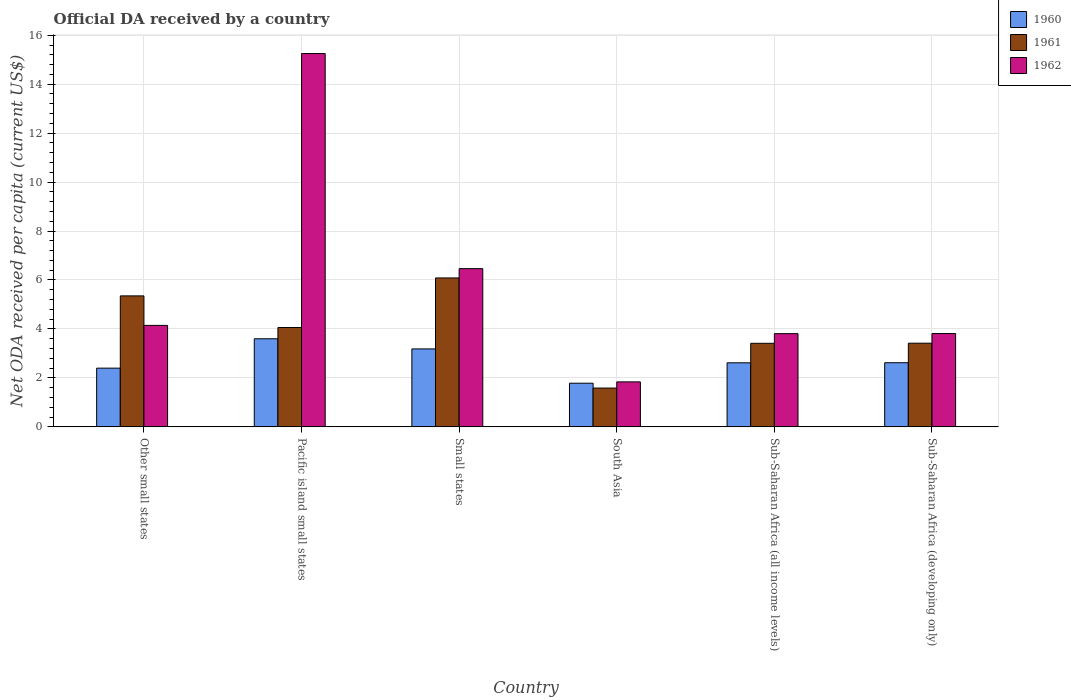How many different coloured bars are there?
Make the answer very short. 3. How many groups of bars are there?
Provide a short and direct response. 6. Are the number of bars on each tick of the X-axis equal?
Your response must be concise. Yes. How many bars are there on the 2nd tick from the left?
Your response must be concise. 3. How many bars are there on the 4th tick from the right?
Your answer should be compact. 3. What is the label of the 2nd group of bars from the left?
Offer a very short reply. Pacific island small states. In how many cases, is the number of bars for a given country not equal to the number of legend labels?
Offer a very short reply. 0. What is the ODA received in in 1961 in Other small states?
Provide a succinct answer. 5.35. Across all countries, what is the maximum ODA received in in 1961?
Make the answer very short. 6.08. Across all countries, what is the minimum ODA received in in 1960?
Your answer should be compact. 1.78. In which country was the ODA received in in 1960 maximum?
Your response must be concise. Pacific island small states. What is the total ODA received in in 1962 in the graph?
Provide a short and direct response. 35.32. What is the difference between the ODA received in in 1961 in Small states and that in Sub-Saharan Africa (developing only)?
Give a very brief answer. 2.67. What is the difference between the ODA received in in 1960 in South Asia and the ODA received in in 1961 in Other small states?
Your answer should be compact. -3.57. What is the average ODA received in in 1961 per country?
Ensure brevity in your answer.  3.99. What is the difference between the ODA received in of/in 1962 and ODA received in of/in 1961 in Small states?
Offer a very short reply. 0.38. In how many countries, is the ODA received in in 1962 greater than 2 US$?
Provide a succinct answer. 5. What is the ratio of the ODA received in in 1961 in Sub-Saharan Africa (all income levels) to that in Sub-Saharan Africa (developing only)?
Offer a terse response. 1. Is the ODA received in in 1961 in Sub-Saharan Africa (all income levels) less than that in Sub-Saharan Africa (developing only)?
Give a very brief answer. Yes. What is the difference between the highest and the second highest ODA received in in 1960?
Ensure brevity in your answer.  0.56. What is the difference between the highest and the lowest ODA received in in 1960?
Provide a short and direct response. 1.82. In how many countries, is the ODA received in in 1962 greater than the average ODA received in in 1962 taken over all countries?
Ensure brevity in your answer.  2. Is the sum of the ODA received in in 1960 in Small states and South Asia greater than the maximum ODA received in in 1962 across all countries?
Provide a succinct answer. No. Is it the case that in every country, the sum of the ODA received in in 1962 and ODA received in in 1961 is greater than the ODA received in in 1960?
Provide a short and direct response. Yes. How many countries are there in the graph?
Offer a very short reply. 6. What is the difference between two consecutive major ticks on the Y-axis?
Your response must be concise. 2. Are the values on the major ticks of Y-axis written in scientific E-notation?
Ensure brevity in your answer.  No. What is the title of the graph?
Give a very brief answer. Official DA received by a country. What is the label or title of the Y-axis?
Give a very brief answer. Net ODA received per capita (current US$). What is the Net ODA received per capita (current US$) of 1960 in Other small states?
Give a very brief answer. 2.4. What is the Net ODA received per capita (current US$) in 1961 in Other small states?
Your response must be concise. 5.35. What is the Net ODA received per capita (current US$) in 1962 in Other small states?
Provide a succinct answer. 4.15. What is the Net ODA received per capita (current US$) of 1960 in Pacific island small states?
Make the answer very short. 3.6. What is the Net ODA received per capita (current US$) of 1961 in Pacific island small states?
Your answer should be very brief. 4.06. What is the Net ODA received per capita (current US$) in 1962 in Pacific island small states?
Give a very brief answer. 15.25. What is the Net ODA received per capita (current US$) in 1960 in Small states?
Your answer should be very brief. 3.18. What is the Net ODA received per capita (current US$) of 1961 in Small states?
Your answer should be very brief. 6.08. What is the Net ODA received per capita (current US$) in 1962 in Small states?
Provide a succinct answer. 6.46. What is the Net ODA received per capita (current US$) of 1960 in South Asia?
Provide a short and direct response. 1.78. What is the Net ODA received per capita (current US$) of 1961 in South Asia?
Offer a terse response. 1.59. What is the Net ODA received per capita (current US$) of 1962 in South Asia?
Provide a short and direct response. 1.84. What is the Net ODA received per capita (current US$) of 1960 in Sub-Saharan Africa (all income levels)?
Offer a very short reply. 2.62. What is the Net ODA received per capita (current US$) of 1961 in Sub-Saharan Africa (all income levels)?
Ensure brevity in your answer.  3.41. What is the Net ODA received per capita (current US$) of 1962 in Sub-Saharan Africa (all income levels)?
Your answer should be compact. 3.81. What is the Net ODA received per capita (current US$) of 1960 in Sub-Saharan Africa (developing only)?
Your answer should be compact. 2.62. What is the Net ODA received per capita (current US$) of 1961 in Sub-Saharan Africa (developing only)?
Give a very brief answer. 3.42. What is the Net ODA received per capita (current US$) in 1962 in Sub-Saharan Africa (developing only)?
Offer a terse response. 3.81. Across all countries, what is the maximum Net ODA received per capita (current US$) in 1960?
Ensure brevity in your answer.  3.6. Across all countries, what is the maximum Net ODA received per capita (current US$) in 1961?
Ensure brevity in your answer.  6.08. Across all countries, what is the maximum Net ODA received per capita (current US$) of 1962?
Your answer should be very brief. 15.25. Across all countries, what is the minimum Net ODA received per capita (current US$) in 1960?
Offer a terse response. 1.78. Across all countries, what is the minimum Net ODA received per capita (current US$) in 1961?
Your answer should be very brief. 1.59. Across all countries, what is the minimum Net ODA received per capita (current US$) of 1962?
Your answer should be very brief. 1.84. What is the total Net ODA received per capita (current US$) of 1960 in the graph?
Provide a succinct answer. 16.2. What is the total Net ODA received per capita (current US$) of 1961 in the graph?
Your answer should be compact. 23.91. What is the total Net ODA received per capita (current US$) of 1962 in the graph?
Provide a short and direct response. 35.32. What is the difference between the Net ODA received per capita (current US$) of 1960 in Other small states and that in Pacific island small states?
Offer a very short reply. -1.2. What is the difference between the Net ODA received per capita (current US$) in 1961 in Other small states and that in Pacific island small states?
Your answer should be very brief. 1.29. What is the difference between the Net ODA received per capita (current US$) in 1962 in Other small states and that in Pacific island small states?
Make the answer very short. -11.11. What is the difference between the Net ODA received per capita (current US$) of 1960 in Other small states and that in Small states?
Keep it short and to the point. -0.79. What is the difference between the Net ODA received per capita (current US$) of 1961 in Other small states and that in Small states?
Offer a terse response. -0.73. What is the difference between the Net ODA received per capita (current US$) of 1962 in Other small states and that in Small states?
Provide a succinct answer. -2.32. What is the difference between the Net ODA received per capita (current US$) of 1960 in Other small states and that in South Asia?
Give a very brief answer. 0.62. What is the difference between the Net ODA received per capita (current US$) of 1961 in Other small states and that in South Asia?
Give a very brief answer. 3.77. What is the difference between the Net ODA received per capita (current US$) in 1962 in Other small states and that in South Asia?
Ensure brevity in your answer.  2.31. What is the difference between the Net ODA received per capita (current US$) of 1960 in Other small states and that in Sub-Saharan Africa (all income levels)?
Give a very brief answer. -0.22. What is the difference between the Net ODA received per capita (current US$) of 1961 in Other small states and that in Sub-Saharan Africa (all income levels)?
Provide a succinct answer. 1.94. What is the difference between the Net ODA received per capita (current US$) in 1962 in Other small states and that in Sub-Saharan Africa (all income levels)?
Your response must be concise. 0.34. What is the difference between the Net ODA received per capita (current US$) of 1960 in Other small states and that in Sub-Saharan Africa (developing only)?
Provide a succinct answer. -0.22. What is the difference between the Net ODA received per capita (current US$) in 1961 in Other small states and that in Sub-Saharan Africa (developing only)?
Offer a terse response. 1.93. What is the difference between the Net ODA received per capita (current US$) in 1962 in Other small states and that in Sub-Saharan Africa (developing only)?
Provide a succinct answer. 0.33. What is the difference between the Net ODA received per capita (current US$) of 1960 in Pacific island small states and that in Small states?
Your answer should be very brief. 0.41. What is the difference between the Net ODA received per capita (current US$) of 1961 in Pacific island small states and that in Small states?
Provide a succinct answer. -2.03. What is the difference between the Net ODA received per capita (current US$) of 1962 in Pacific island small states and that in Small states?
Keep it short and to the point. 8.79. What is the difference between the Net ODA received per capita (current US$) of 1960 in Pacific island small states and that in South Asia?
Keep it short and to the point. 1.82. What is the difference between the Net ODA received per capita (current US$) in 1961 in Pacific island small states and that in South Asia?
Give a very brief answer. 2.47. What is the difference between the Net ODA received per capita (current US$) of 1962 in Pacific island small states and that in South Asia?
Offer a very short reply. 13.41. What is the difference between the Net ODA received per capita (current US$) of 1960 in Pacific island small states and that in Sub-Saharan Africa (all income levels)?
Provide a succinct answer. 0.98. What is the difference between the Net ODA received per capita (current US$) in 1961 in Pacific island small states and that in Sub-Saharan Africa (all income levels)?
Your answer should be compact. 0.64. What is the difference between the Net ODA received per capita (current US$) in 1962 in Pacific island small states and that in Sub-Saharan Africa (all income levels)?
Make the answer very short. 11.44. What is the difference between the Net ODA received per capita (current US$) of 1960 in Pacific island small states and that in Sub-Saharan Africa (developing only)?
Keep it short and to the point. 0.98. What is the difference between the Net ODA received per capita (current US$) of 1961 in Pacific island small states and that in Sub-Saharan Africa (developing only)?
Your response must be concise. 0.64. What is the difference between the Net ODA received per capita (current US$) in 1962 in Pacific island small states and that in Sub-Saharan Africa (developing only)?
Your answer should be very brief. 11.44. What is the difference between the Net ODA received per capita (current US$) of 1960 in Small states and that in South Asia?
Your response must be concise. 1.4. What is the difference between the Net ODA received per capita (current US$) in 1961 in Small states and that in South Asia?
Provide a succinct answer. 4.5. What is the difference between the Net ODA received per capita (current US$) in 1962 in Small states and that in South Asia?
Your answer should be very brief. 4.63. What is the difference between the Net ODA received per capita (current US$) in 1960 in Small states and that in Sub-Saharan Africa (all income levels)?
Give a very brief answer. 0.57. What is the difference between the Net ODA received per capita (current US$) of 1961 in Small states and that in Sub-Saharan Africa (all income levels)?
Your answer should be very brief. 2.67. What is the difference between the Net ODA received per capita (current US$) in 1962 in Small states and that in Sub-Saharan Africa (all income levels)?
Keep it short and to the point. 2.66. What is the difference between the Net ODA received per capita (current US$) in 1960 in Small states and that in Sub-Saharan Africa (developing only)?
Provide a short and direct response. 0.56. What is the difference between the Net ODA received per capita (current US$) in 1961 in Small states and that in Sub-Saharan Africa (developing only)?
Make the answer very short. 2.67. What is the difference between the Net ODA received per capita (current US$) in 1962 in Small states and that in Sub-Saharan Africa (developing only)?
Provide a short and direct response. 2.65. What is the difference between the Net ODA received per capita (current US$) in 1960 in South Asia and that in Sub-Saharan Africa (all income levels)?
Give a very brief answer. -0.83. What is the difference between the Net ODA received per capita (current US$) of 1961 in South Asia and that in Sub-Saharan Africa (all income levels)?
Make the answer very short. -1.83. What is the difference between the Net ODA received per capita (current US$) of 1962 in South Asia and that in Sub-Saharan Africa (all income levels)?
Ensure brevity in your answer.  -1.97. What is the difference between the Net ODA received per capita (current US$) of 1960 in South Asia and that in Sub-Saharan Africa (developing only)?
Provide a short and direct response. -0.84. What is the difference between the Net ODA received per capita (current US$) in 1961 in South Asia and that in Sub-Saharan Africa (developing only)?
Offer a terse response. -1.83. What is the difference between the Net ODA received per capita (current US$) in 1962 in South Asia and that in Sub-Saharan Africa (developing only)?
Offer a terse response. -1.98. What is the difference between the Net ODA received per capita (current US$) of 1960 in Sub-Saharan Africa (all income levels) and that in Sub-Saharan Africa (developing only)?
Provide a succinct answer. -0. What is the difference between the Net ODA received per capita (current US$) in 1961 in Sub-Saharan Africa (all income levels) and that in Sub-Saharan Africa (developing only)?
Provide a succinct answer. -0. What is the difference between the Net ODA received per capita (current US$) in 1962 in Sub-Saharan Africa (all income levels) and that in Sub-Saharan Africa (developing only)?
Offer a very short reply. -0. What is the difference between the Net ODA received per capita (current US$) of 1960 in Other small states and the Net ODA received per capita (current US$) of 1961 in Pacific island small states?
Offer a very short reply. -1.66. What is the difference between the Net ODA received per capita (current US$) of 1960 in Other small states and the Net ODA received per capita (current US$) of 1962 in Pacific island small states?
Your answer should be very brief. -12.85. What is the difference between the Net ODA received per capita (current US$) in 1961 in Other small states and the Net ODA received per capita (current US$) in 1962 in Pacific island small states?
Ensure brevity in your answer.  -9.9. What is the difference between the Net ODA received per capita (current US$) of 1960 in Other small states and the Net ODA received per capita (current US$) of 1961 in Small states?
Offer a terse response. -3.69. What is the difference between the Net ODA received per capita (current US$) in 1960 in Other small states and the Net ODA received per capita (current US$) in 1962 in Small states?
Keep it short and to the point. -4.06. What is the difference between the Net ODA received per capita (current US$) of 1961 in Other small states and the Net ODA received per capita (current US$) of 1962 in Small states?
Offer a very short reply. -1.11. What is the difference between the Net ODA received per capita (current US$) in 1960 in Other small states and the Net ODA received per capita (current US$) in 1961 in South Asia?
Your answer should be very brief. 0.81. What is the difference between the Net ODA received per capita (current US$) of 1960 in Other small states and the Net ODA received per capita (current US$) of 1962 in South Asia?
Ensure brevity in your answer.  0.56. What is the difference between the Net ODA received per capita (current US$) in 1961 in Other small states and the Net ODA received per capita (current US$) in 1962 in South Asia?
Your response must be concise. 3.51. What is the difference between the Net ODA received per capita (current US$) in 1960 in Other small states and the Net ODA received per capita (current US$) in 1961 in Sub-Saharan Africa (all income levels)?
Your answer should be compact. -1.02. What is the difference between the Net ODA received per capita (current US$) of 1960 in Other small states and the Net ODA received per capita (current US$) of 1962 in Sub-Saharan Africa (all income levels)?
Ensure brevity in your answer.  -1.41. What is the difference between the Net ODA received per capita (current US$) of 1961 in Other small states and the Net ODA received per capita (current US$) of 1962 in Sub-Saharan Africa (all income levels)?
Offer a very short reply. 1.54. What is the difference between the Net ODA received per capita (current US$) in 1960 in Other small states and the Net ODA received per capita (current US$) in 1961 in Sub-Saharan Africa (developing only)?
Give a very brief answer. -1.02. What is the difference between the Net ODA received per capita (current US$) of 1960 in Other small states and the Net ODA received per capita (current US$) of 1962 in Sub-Saharan Africa (developing only)?
Your answer should be very brief. -1.41. What is the difference between the Net ODA received per capita (current US$) in 1961 in Other small states and the Net ODA received per capita (current US$) in 1962 in Sub-Saharan Africa (developing only)?
Offer a very short reply. 1.54. What is the difference between the Net ODA received per capita (current US$) in 1960 in Pacific island small states and the Net ODA received per capita (current US$) in 1961 in Small states?
Provide a succinct answer. -2.48. What is the difference between the Net ODA received per capita (current US$) in 1960 in Pacific island small states and the Net ODA received per capita (current US$) in 1962 in Small states?
Keep it short and to the point. -2.86. What is the difference between the Net ODA received per capita (current US$) in 1961 in Pacific island small states and the Net ODA received per capita (current US$) in 1962 in Small states?
Keep it short and to the point. -2.41. What is the difference between the Net ODA received per capita (current US$) of 1960 in Pacific island small states and the Net ODA received per capita (current US$) of 1961 in South Asia?
Ensure brevity in your answer.  2.01. What is the difference between the Net ODA received per capita (current US$) of 1960 in Pacific island small states and the Net ODA received per capita (current US$) of 1962 in South Asia?
Your answer should be very brief. 1.76. What is the difference between the Net ODA received per capita (current US$) in 1961 in Pacific island small states and the Net ODA received per capita (current US$) in 1962 in South Asia?
Offer a terse response. 2.22. What is the difference between the Net ODA received per capita (current US$) in 1960 in Pacific island small states and the Net ODA received per capita (current US$) in 1961 in Sub-Saharan Africa (all income levels)?
Your answer should be compact. 0.18. What is the difference between the Net ODA received per capita (current US$) in 1960 in Pacific island small states and the Net ODA received per capita (current US$) in 1962 in Sub-Saharan Africa (all income levels)?
Give a very brief answer. -0.21. What is the difference between the Net ODA received per capita (current US$) of 1961 in Pacific island small states and the Net ODA received per capita (current US$) of 1962 in Sub-Saharan Africa (all income levels)?
Provide a short and direct response. 0.25. What is the difference between the Net ODA received per capita (current US$) in 1960 in Pacific island small states and the Net ODA received per capita (current US$) in 1961 in Sub-Saharan Africa (developing only)?
Your answer should be very brief. 0.18. What is the difference between the Net ODA received per capita (current US$) in 1960 in Pacific island small states and the Net ODA received per capita (current US$) in 1962 in Sub-Saharan Africa (developing only)?
Your response must be concise. -0.21. What is the difference between the Net ODA received per capita (current US$) in 1961 in Pacific island small states and the Net ODA received per capita (current US$) in 1962 in Sub-Saharan Africa (developing only)?
Keep it short and to the point. 0.25. What is the difference between the Net ODA received per capita (current US$) of 1960 in Small states and the Net ODA received per capita (current US$) of 1961 in South Asia?
Provide a succinct answer. 1.6. What is the difference between the Net ODA received per capita (current US$) of 1960 in Small states and the Net ODA received per capita (current US$) of 1962 in South Asia?
Your answer should be very brief. 1.35. What is the difference between the Net ODA received per capita (current US$) in 1961 in Small states and the Net ODA received per capita (current US$) in 1962 in South Asia?
Provide a short and direct response. 4.25. What is the difference between the Net ODA received per capita (current US$) in 1960 in Small states and the Net ODA received per capita (current US$) in 1961 in Sub-Saharan Africa (all income levels)?
Offer a terse response. -0.23. What is the difference between the Net ODA received per capita (current US$) of 1960 in Small states and the Net ODA received per capita (current US$) of 1962 in Sub-Saharan Africa (all income levels)?
Provide a succinct answer. -0.62. What is the difference between the Net ODA received per capita (current US$) of 1961 in Small states and the Net ODA received per capita (current US$) of 1962 in Sub-Saharan Africa (all income levels)?
Your response must be concise. 2.28. What is the difference between the Net ODA received per capita (current US$) in 1960 in Small states and the Net ODA received per capita (current US$) in 1961 in Sub-Saharan Africa (developing only)?
Provide a succinct answer. -0.23. What is the difference between the Net ODA received per capita (current US$) of 1960 in Small states and the Net ODA received per capita (current US$) of 1962 in Sub-Saharan Africa (developing only)?
Your answer should be very brief. -0.63. What is the difference between the Net ODA received per capita (current US$) of 1961 in Small states and the Net ODA received per capita (current US$) of 1962 in Sub-Saharan Africa (developing only)?
Provide a succinct answer. 2.27. What is the difference between the Net ODA received per capita (current US$) in 1960 in South Asia and the Net ODA received per capita (current US$) in 1961 in Sub-Saharan Africa (all income levels)?
Offer a very short reply. -1.63. What is the difference between the Net ODA received per capita (current US$) of 1960 in South Asia and the Net ODA received per capita (current US$) of 1962 in Sub-Saharan Africa (all income levels)?
Your response must be concise. -2.02. What is the difference between the Net ODA received per capita (current US$) of 1961 in South Asia and the Net ODA received per capita (current US$) of 1962 in Sub-Saharan Africa (all income levels)?
Your response must be concise. -2.22. What is the difference between the Net ODA received per capita (current US$) in 1960 in South Asia and the Net ODA received per capita (current US$) in 1961 in Sub-Saharan Africa (developing only)?
Keep it short and to the point. -1.64. What is the difference between the Net ODA received per capita (current US$) of 1960 in South Asia and the Net ODA received per capita (current US$) of 1962 in Sub-Saharan Africa (developing only)?
Your answer should be compact. -2.03. What is the difference between the Net ODA received per capita (current US$) of 1961 in South Asia and the Net ODA received per capita (current US$) of 1962 in Sub-Saharan Africa (developing only)?
Your answer should be very brief. -2.23. What is the difference between the Net ODA received per capita (current US$) in 1960 in Sub-Saharan Africa (all income levels) and the Net ODA received per capita (current US$) in 1961 in Sub-Saharan Africa (developing only)?
Your answer should be compact. -0.8. What is the difference between the Net ODA received per capita (current US$) of 1960 in Sub-Saharan Africa (all income levels) and the Net ODA received per capita (current US$) of 1962 in Sub-Saharan Africa (developing only)?
Your answer should be very brief. -1.2. What is the difference between the Net ODA received per capita (current US$) of 1961 in Sub-Saharan Africa (all income levels) and the Net ODA received per capita (current US$) of 1962 in Sub-Saharan Africa (developing only)?
Provide a succinct answer. -0.4. What is the average Net ODA received per capita (current US$) of 1960 per country?
Your answer should be compact. 2.7. What is the average Net ODA received per capita (current US$) in 1961 per country?
Your response must be concise. 3.99. What is the average Net ODA received per capita (current US$) of 1962 per country?
Keep it short and to the point. 5.89. What is the difference between the Net ODA received per capita (current US$) in 1960 and Net ODA received per capita (current US$) in 1961 in Other small states?
Keep it short and to the point. -2.95. What is the difference between the Net ODA received per capita (current US$) of 1960 and Net ODA received per capita (current US$) of 1962 in Other small states?
Ensure brevity in your answer.  -1.75. What is the difference between the Net ODA received per capita (current US$) in 1961 and Net ODA received per capita (current US$) in 1962 in Other small states?
Your answer should be very brief. 1.21. What is the difference between the Net ODA received per capita (current US$) of 1960 and Net ODA received per capita (current US$) of 1961 in Pacific island small states?
Ensure brevity in your answer.  -0.46. What is the difference between the Net ODA received per capita (current US$) of 1960 and Net ODA received per capita (current US$) of 1962 in Pacific island small states?
Keep it short and to the point. -11.65. What is the difference between the Net ODA received per capita (current US$) of 1961 and Net ODA received per capita (current US$) of 1962 in Pacific island small states?
Give a very brief answer. -11.19. What is the difference between the Net ODA received per capita (current US$) of 1960 and Net ODA received per capita (current US$) of 1961 in Small states?
Keep it short and to the point. -2.9. What is the difference between the Net ODA received per capita (current US$) in 1960 and Net ODA received per capita (current US$) in 1962 in Small states?
Your response must be concise. -3.28. What is the difference between the Net ODA received per capita (current US$) in 1961 and Net ODA received per capita (current US$) in 1962 in Small states?
Offer a very short reply. -0.38. What is the difference between the Net ODA received per capita (current US$) of 1960 and Net ODA received per capita (current US$) of 1961 in South Asia?
Offer a terse response. 0.2. What is the difference between the Net ODA received per capita (current US$) in 1960 and Net ODA received per capita (current US$) in 1962 in South Asia?
Provide a short and direct response. -0.05. What is the difference between the Net ODA received per capita (current US$) in 1961 and Net ODA received per capita (current US$) in 1962 in South Asia?
Provide a succinct answer. -0.25. What is the difference between the Net ODA received per capita (current US$) of 1960 and Net ODA received per capita (current US$) of 1961 in Sub-Saharan Africa (all income levels)?
Provide a succinct answer. -0.8. What is the difference between the Net ODA received per capita (current US$) in 1960 and Net ODA received per capita (current US$) in 1962 in Sub-Saharan Africa (all income levels)?
Offer a very short reply. -1.19. What is the difference between the Net ODA received per capita (current US$) of 1961 and Net ODA received per capita (current US$) of 1962 in Sub-Saharan Africa (all income levels)?
Your answer should be compact. -0.39. What is the difference between the Net ODA received per capita (current US$) of 1960 and Net ODA received per capita (current US$) of 1961 in Sub-Saharan Africa (developing only)?
Make the answer very short. -0.8. What is the difference between the Net ODA received per capita (current US$) of 1960 and Net ODA received per capita (current US$) of 1962 in Sub-Saharan Africa (developing only)?
Provide a succinct answer. -1.19. What is the difference between the Net ODA received per capita (current US$) of 1961 and Net ODA received per capita (current US$) of 1962 in Sub-Saharan Africa (developing only)?
Offer a terse response. -0.39. What is the ratio of the Net ODA received per capita (current US$) of 1960 in Other small states to that in Pacific island small states?
Keep it short and to the point. 0.67. What is the ratio of the Net ODA received per capita (current US$) of 1961 in Other small states to that in Pacific island small states?
Make the answer very short. 1.32. What is the ratio of the Net ODA received per capita (current US$) of 1962 in Other small states to that in Pacific island small states?
Make the answer very short. 0.27. What is the ratio of the Net ODA received per capita (current US$) of 1960 in Other small states to that in Small states?
Keep it short and to the point. 0.75. What is the ratio of the Net ODA received per capita (current US$) of 1961 in Other small states to that in Small states?
Your answer should be compact. 0.88. What is the ratio of the Net ODA received per capita (current US$) in 1962 in Other small states to that in Small states?
Your answer should be compact. 0.64. What is the ratio of the Net ODA received per capita (current US$) in 1960 in Other small states to that in South Asia?
Offer a very short reply. 1.35. What is the ratio of the Net ODA received per capita (current US$) in 1961 in Other small states to that in South Asia?
Your response must be concise. 3.37. What is the ratio of the Net ODA received per capita (current US$) in 1962 in Other small states to that in South Asia?
Provide a short and direct response. 2.26. What is the ratio of the Net ODA received per capita (current US$) in 1961 in Other small states to that in Sub-Saharan Africa (all income levels)?
Provide a succinct answer. 1.57. What is the ratio of the Net ODA received per capita (current US$) in 1962 in Other small states to that in Sub-Saharan Africa (all income levels)?
Provide a short and direct response. 1.09. What is the ratio of the Net ODA received per capita (current US$) of 1960 in Other small states to that in Sub-Saharan Africa (developing only)?
Your answer should be compact. 0.92. What is the ratio of the Net ODA received per capita (current US$) in 1961 in Other small states to that in Sub-Saharan Africa (developing only)?
Keep it short and to the point. 1.57. What is the ratio of the Net ODA received per capita (current US$) in 1962 in Other small states to that in Sub-Saharan Africa (developing only)?
Ensure brevity in your answer.  1.09. What is the ratio of the Net ODA received per capita (current US$) in 1960 in Pacific island small states to that in Small states?
Keep it short and to the point. 1.13. What is the ratio of the Net ODA received per capita (current US$) of 1961 in Pacific island small states to that in Small states?
Give a very brief answer. 0.67. What is the ratio of the Net ODA received per capita (current US$) of 1962 in Pacific island small states to that in Small states?
Make the answer very short. 2.36. What is the ratio of the Net ODA received per capita (current US$) of 1960 in Pacific island small states to that in South Asia?
Provide a short and direct response. 2.02. What is the ratio of the Net ODA received per capita (current US$) in 1961 in Pacific island small states to that in South Asia?
Offer a very short reply. 2.56. What is the ratio of the Net ODA received per capita (current US$) in 1962 in Pacific island small states to that in South Asia?
Offer a terse response. 8.3. What is the ratio of the Net ODA received per capita (current US$) in 1960 in Pacific island small states to that in Sub-Saharan Africa (all income levels)?
Make the answer very short. 1.38. What is the ratio of the Net ODA received per capita (current US$) in 1961 in Pacific island small states to that in Sub-Saharan Africa (all income levels)?
Your answer should be compact. 1.19. What is the ratio of the Net ODA received per capita (current US$) of 1962 in Pacific island small states to that in Sub-Saharan Africa (all income levels)?
Keep it short and to the point. 4. What is the ratio of the Net ODA received per capita (current US$) in 1960 in Pacific island small states to that in Sub-Saharan Africa (developing only)?
Offer a terse response. 1.37. What is the ratio of the Net ODA received per capita (current US$) in 1961 in Pacific island small states to that in Sub-Saharan Africa (developing only)?
Make the answer very short. 1.19. What is the ratio of the Net ODA received per capita (current US$) in 1962 in Pacific island small states to that in Sub-Saharan Africa (developing only)?
Keep it short and to the point. 4. What is the ratio of the Net ODA received per capita (current US$) in 1960 in Small states to that in South Asia?
Your response must be concise. 1.79. What is the ratio of the Net ODA received per capita (current US$) in 1961 in Small states to that in South Asia?
Make the answer very short. 3.84. What is the ratio of the Net ODA received per capita (current US$) of 1962 in Small states to that in South Asia?
Provide a short and direct response. 3.52. What is the ratio of the Net ODA received per capita (current US$) in 1960 in Small states to that in Sub-Saharan Africa (all income levels)?
Provide a succinct answer. 1.22. What is the ratio of the Net ODA received per capita (current US$) of 1961 in Small states to that in Sub-Saharan Africa (all income levels)?
Provide a succinct answer. 1.78. What is the ratio of the Net ODA received per capita (current US$) in 1962 in Small states to that in Sub-Saharan Africa (all income levels)?
Provide a short and direct response. 1.7. What is the ratio of the Net ODA received per capita (current US$) of 1960 in Small states to that in Sub-Saharan Africa (developing only)?
Provide a short and direct response. 1.22. What is the ratio of the Net ODA received per capita (current US$) of 1961 in Small states to that in Sub-Saharan Africa (developing only)?
Ensure brevity in your answer.  1.78. What is the ratio of the Net ODA received per capita (current US$) of 1962 in Small states to that in Sub-Saharan Africa (developing only)?
Make the answer very short. 1.7. What is the ratio of the Net ODA received per capita (current US$) in 1960 in South Asia to that in Sub-Saharan Africa (all income levels)?
Ensure brevity in your answer.  0.68. What is the ratio of the Net ODA received per capita (current US$) in 1961 in South Asia to that in Sub-Saharan Africa (all income levels)?
Ensure brevity in your answer.  0.46. What is the ratio of the Net ODA received per capita (current US$) of 1962 in South Asia to that in Sub-Saharan Africa (all income levels)?
Make the answer very short. 0.48. What is the ratio of the Net ODA received per capita (current US$) of 1960 in South Asia to that in Sub-Saharan Africa (developing only)?
Your answer should be compact. 0.68. What is the ratio of the Net ODA received per capita (current US$) of 1961 in South Asia to that in Sub-Saharan Africa (developing only)?
Your answer should be very brief. 0.46. What is the ratio of the Net ODA received per capita (current US$) of 1962 in South Asia to that in Sub-Saharan Africa (developing only)?
Provide a short and direct response. 0.48. What is the ratio of the Net ODA received per capita (current US$) of 1962 in Sub-Saharan Africa (all income levels) to that in Sub-Saharan Africa (developing only)?
Give a very brief answer. 1. What is the difference between the highest and the second highest Net ODA received per capita (current US$) of 1960?
Offer a very short reply. 0.41. What is the difference between the highest and the second highest Net ODA received per capita (current US$) in 1961?
Your answer should be compact. 0.73. What is the difference between the highest and the second highest Net ODA received per capita (current US$) of 1962?
Give a very brief answer. 8.79. What is the difference between the highest and the lowest Net ODA received per capita (current US$) of 1960?
Ensure brevity in your answer.  1.82. What is the difference between the highest and the lowest Net ODA received per capita (current US$) of 1961?
Give a very brief answer. 4.5. What is the difference between the highest and the lowest Net ODA received per capita (current US$) in 1962?
Give a very brief answer. 13.41. 